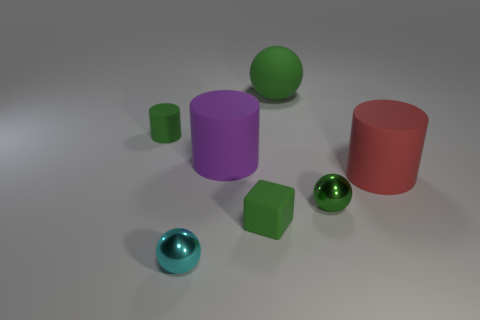What number of other objects are the same size as the cyan ball?
Provide a succinct answer. 3. What is the material of the small thing that is on the left side of the green rubber cube and in front of the green shiny thing?
Your response must be concise. Metal. There is a metal thing that is right of the purple thing; is it the same shape as the big matte thing that is on the right side of the matte sphere?
Offer a very short reply. No. There is a green rubber object that is in front of the big rubber object that is right of the tiny green metal ball in front of the rubber ball; what is its shape?
Provide a succinct answer. Cube. What number of other things are there of the same shape as the purple object?
Give a very brief answer. 2. There is a cube that is the same size as the cyan object; what color is it?
Your answer should be very brief. Green. What number of spheres are large purple matte things or cyan things?
Your answer should be compact. 1. What number of green objects are there?
Your response must be concise. 4. There is a red matte object; is it the same shape as the rubber object in front of the red matte cylinder?
Provide a succinct answer. No. There is a matte ball that is the same color as the small matte cylinder; what is its size?
Your answer should be compact. Large. 